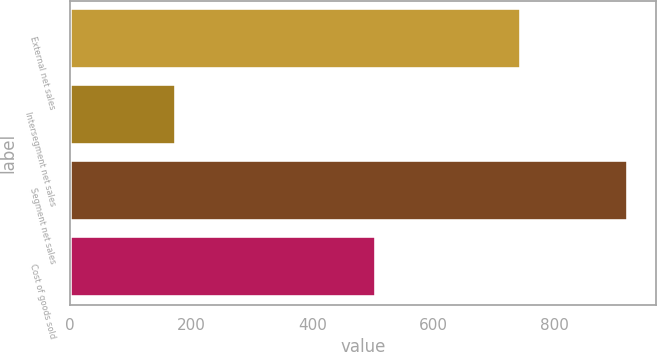Convert chart. <chart><loc_0><loc_0><loc_500><loc_500><bar_chart><fcel>External net sales<fcel>Intersegment net sales<fcel>Segment net sales<fcel>Cost of goods sold<nl><fcel>744.9<fcel>175.7<fcel>920.6<fcel>504.3<nl></chart> 